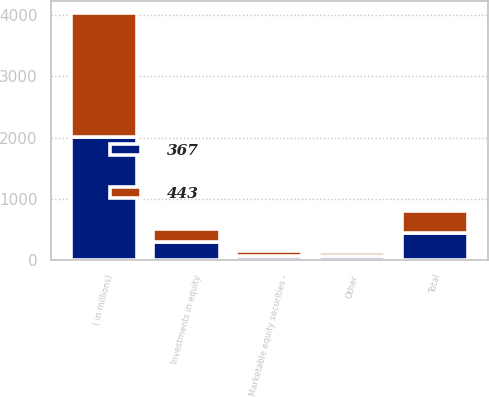<chart> <loc_0><loc_0><loc_500><loc_500><stacked_bar_chart><ecel><fcel>( in millions)<fcel>Investments in equity<fcel>Marketable equity securities -<fcel>Other<fcel>Total<nl><fcel>443<fcel>2015<fcel>221<fcel>77<fcel>69<fcel>367<nl><fcel>367<fcel>2014<fcel>295<fcel>74<fcel>74<fcel>443<nl></chart> 